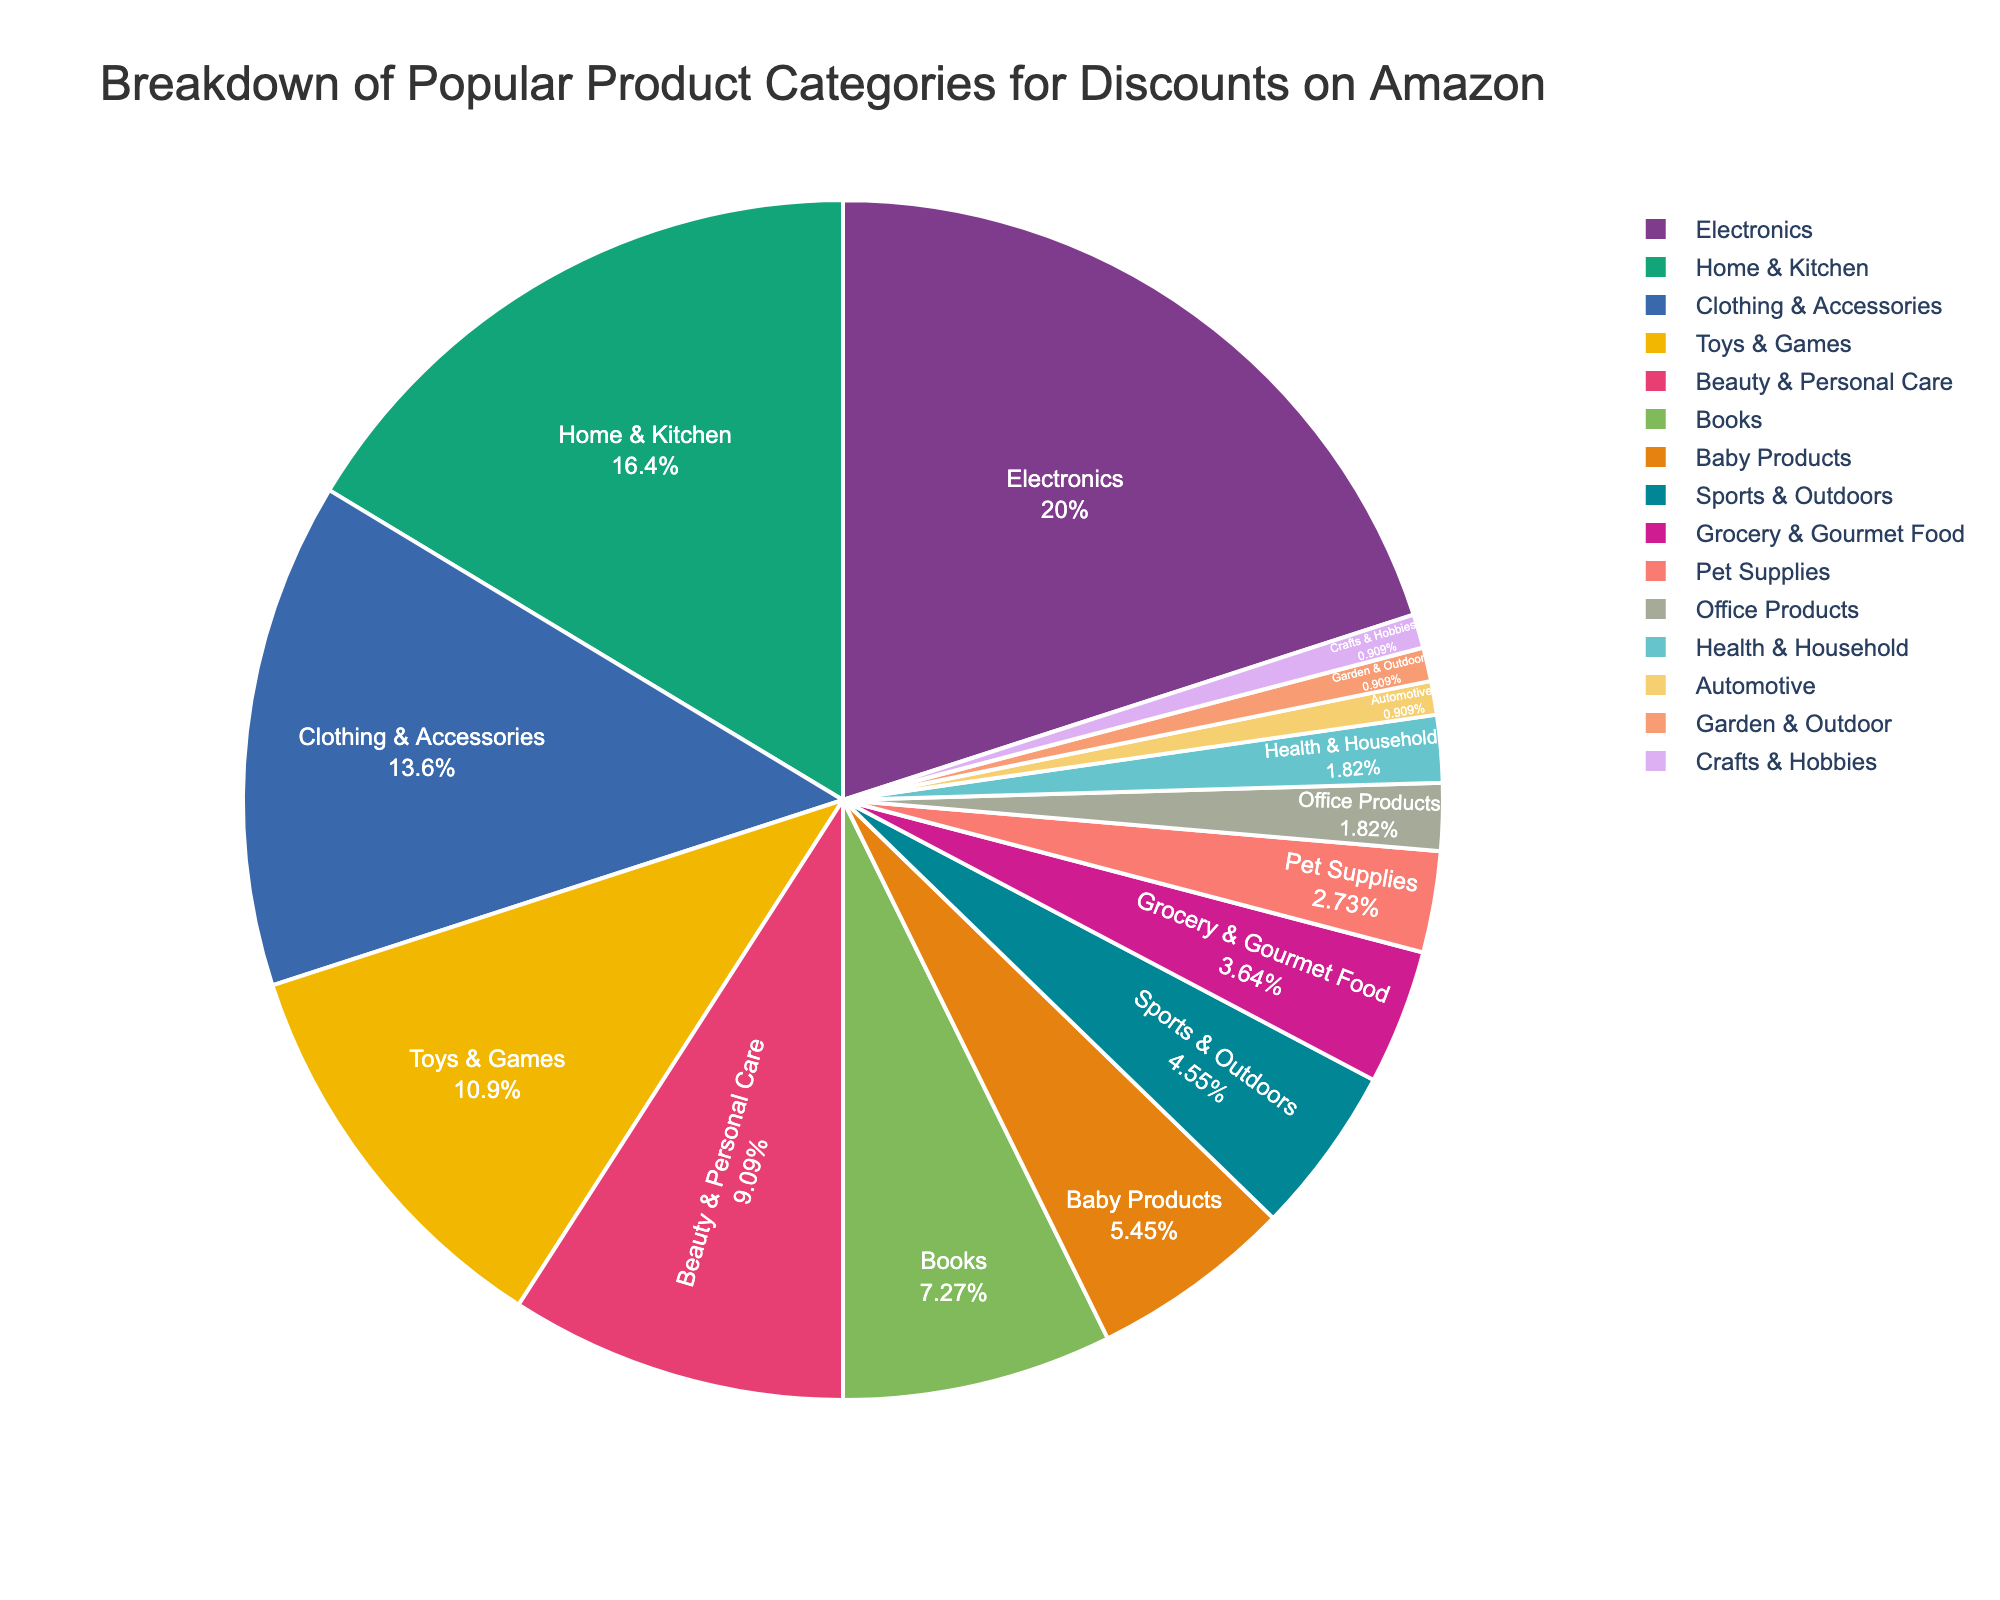What's the largest category for discounts on Amazon? The largest category for discounts on Amazon is the one with the highest percentage shown in the pie chart. This category is "Electronics" with 22%.
Answer: Electronics Which category has a higher percentage of discounts: Home & Kitchen or Clothing & Accessories? Compare the percentages for "Home & Kitchen" and "Clothing & Accessories" from the pie chart. "Home & Kitchen" has 18%, and "Clothing & Accessories" has 15%. 18% is greater than 15%.
Answer: Home & Kitchen What is the combined percentage for categories below 5%? Calculate the sum of the percentages for categories below 5%: Baby Products (6%) + Sports & Outdoors (5%) + Grocery & Gourmet Food (4%) + Pet Supplies (3%) + Office Products (2%) + Health & Household (2%) + Automotive (1%) + Garden & Outdoor (1%) + Crafts & Hobbies (1%). The total is 25%.
Answer: 25% If you want to focus on the top three categories for discounts, which ones should you look at? Identify the three categories with the highest percentages from the pie chart: Electronics (22%), Home & Kitchen (18%), and Clothing & Accessories (15%).
Answer: Electronics, Home & Kitchen, Clothing & Accessories Are there more categories with percentages above or below 5%? Count the categories above and below 5%. Categories above 5% are: Electronics, Home & Kitchen, Clothing & Accessories, Toys & Games, Beauty & Personal Care, and Books (6 categories). Categories below 5% are: Baby Products, Sports & Outdoors, Grocery & Gourmet Food, Pet Supplies, Office Products, Health & Household, Automotive, Garden & Outdoor, and Crafts & Hobbies (9 categories). There are more categories below 5%.
Answer: Below 5% What is the total percentage for Home & Kitchen and Health & Household combined? Add the percentages for "Home & Kitchen" and "Health & Household": 18% + 2% equals 20%.
Answer: 20% Which category has the least percentage of discounts on Amazon? The category with the lowest percentage is the one with 1% in the pie chart. These are Automotive, Garden & Outdoor, and Crafts & Hobbies.
Answer: Automotive, Garden & Outdoor, Crafts & Hobbies How does the percentage of discounts in Beauty & Personal Care compare to that in Books? Compare the percentages for "Beauty & Personal Care" (10%) and "Books" (8%). Beauty & Personal Care has a higher percentage than Books.
Answer: Beauty & Personal Care has a higher percentage than Books If you combine the percentages of Pet Supplies and Baby Products, how does their total compare to that of Toys & Games? Add the percentages for "Pet Supplies" and "Baby Products": 3% + 6% equals 9%. Then compare this to the percentage for "Toys & Games" (12%). 9% is less than 12%.
Answer: Less 